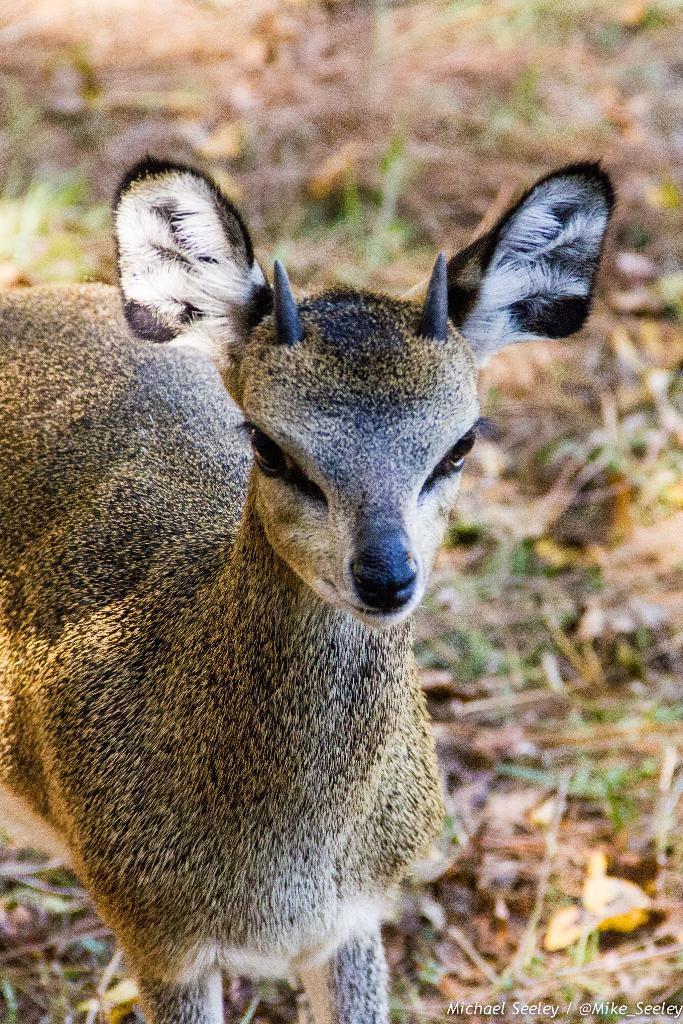How would you summarize this image in a sentence or two? In this picture there is an animal in the center of the image, there is dry grass on the floor. 